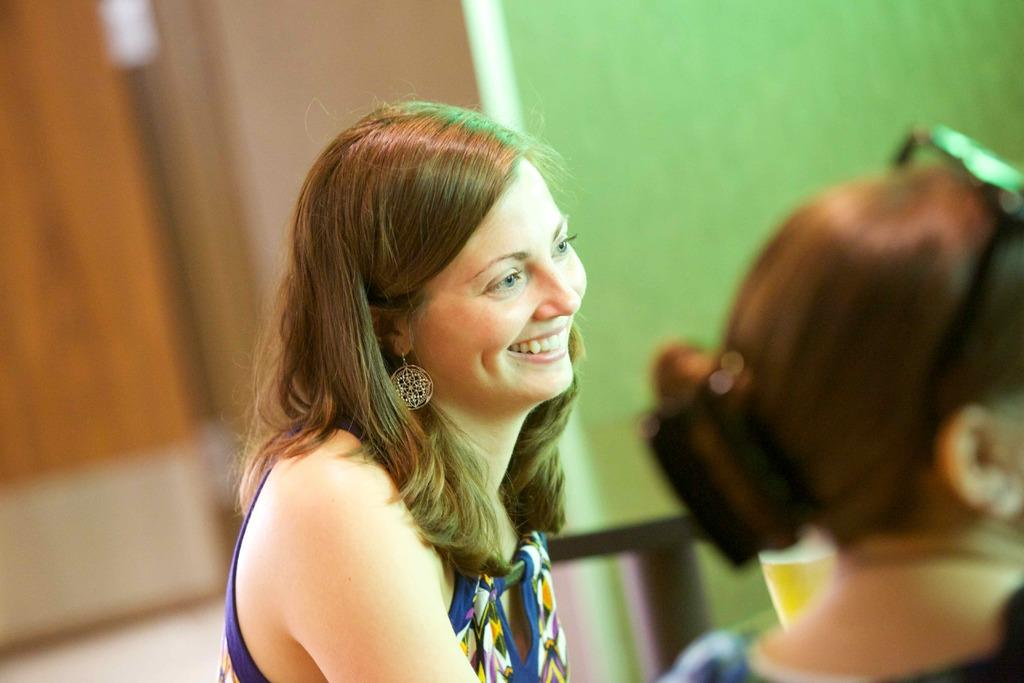How many people are in the image? There are two women in the image. What can be seen in the background of the image? There are objects in the background of the image. What type of structure is visible in the background? There is a wall in the background of the image. What type of hydrant is present in the image? There is no hydrant present in the image. What knowledge is being shared between the two women in the image? The image does not provide any information about the conversation or knowledge being shared between the two women. 